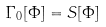Convert formula to latex. <formula><loc_0><loc_0><loc_500><loc_500>\Gamma _ { 0 } [ \Phi ] = S [ \Phi ]</formula> 